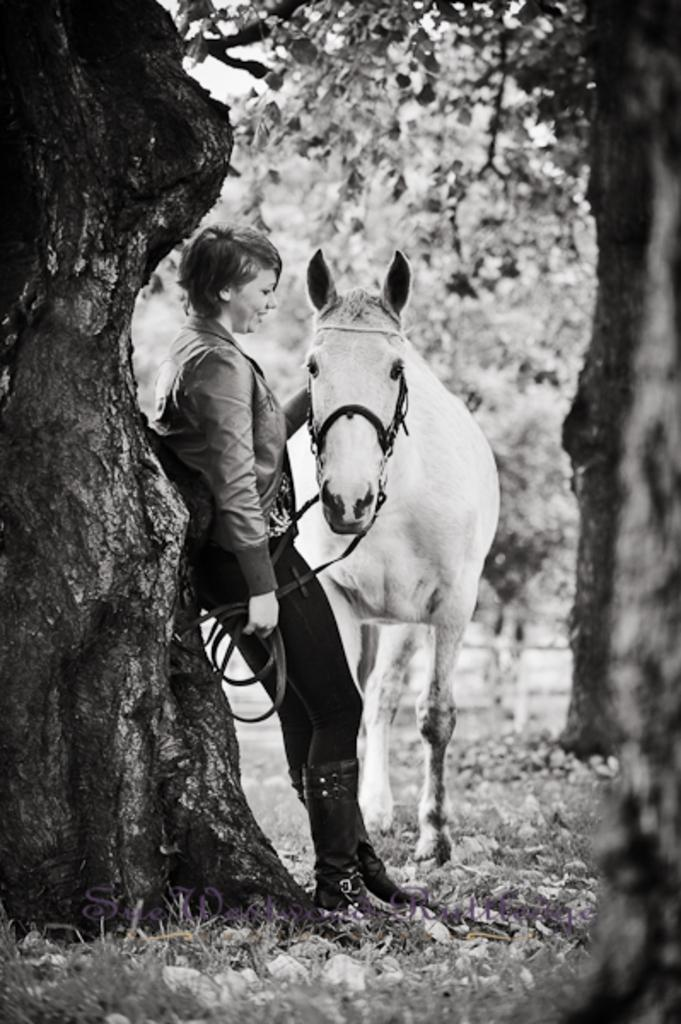What is the color scheme of the image? The image is in black and white. Who is present in the image? There is a lady in the image. What is the lady holding in the image? The lady is holding a horse. What type of vegetation can be seen in the image? There is grass and plants visible in the image. How many planes can be seen flying in the image? There are no planes visible in the image; it features a lady holding a horse. What type of dinner is being served in the image? There is no dinner present in the image; it is a black and white image of a dinner scene. 